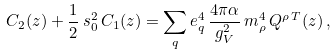<formula> <loc_0><loc_0><loc_500><loc_500>C _ { 2 } ( z ) + \frac { 1 } { 2 } \, s _ { 0 } ^ { 2 } \, C _ { 1 } ( z ) = \sum _ { q } e ^ { 4 } _ { q } \, \frac { 4 \pi \alpha } { g ^ { 2 } _ { V } } \, m _ { \rho } ^ { 4 } \, Q ^ { \rho \, T } ( z ) \, ,</formula> 